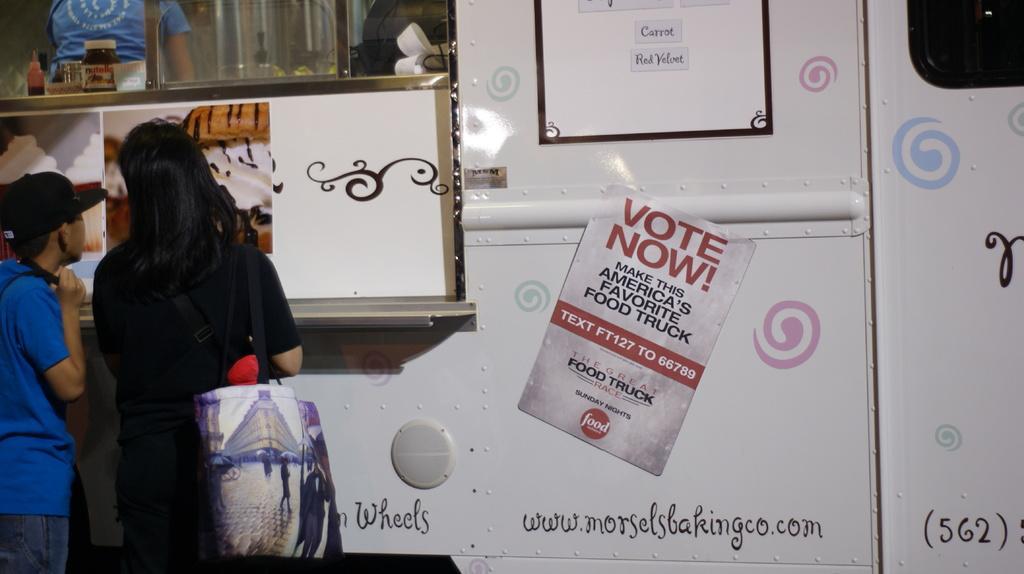Please provide a concise description of this image. Here we can see two persons. In the background we can see a vehicle, posters, glass, and bottles. There is a bag. Here we can see a person inside a vehicle. 